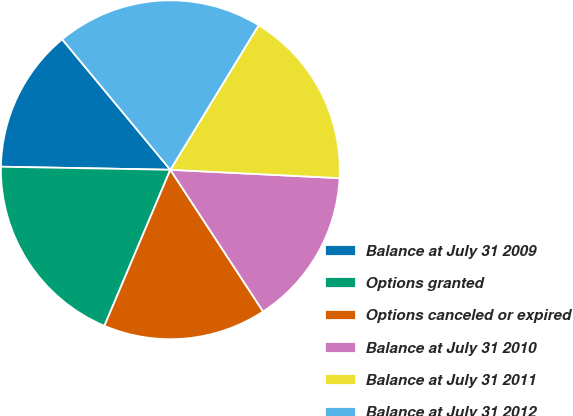Convert chart. <chart><loc_0><loc_0><loc_500><loc_500><pie_chart><fcel>Balance at July 31 2009<fcel>Options granted<fcel>Options canceled or expired<fcel>Balance at July 31 2010<fcel>Balance at July 31 2011<fcel>Balance at July 31 2012<nl><fcel>13.7%<fcel>18.93%<fcel>15.59%<fcel>14.99%<fcel>17.06%<fcel>19.75%<nl></chart> 